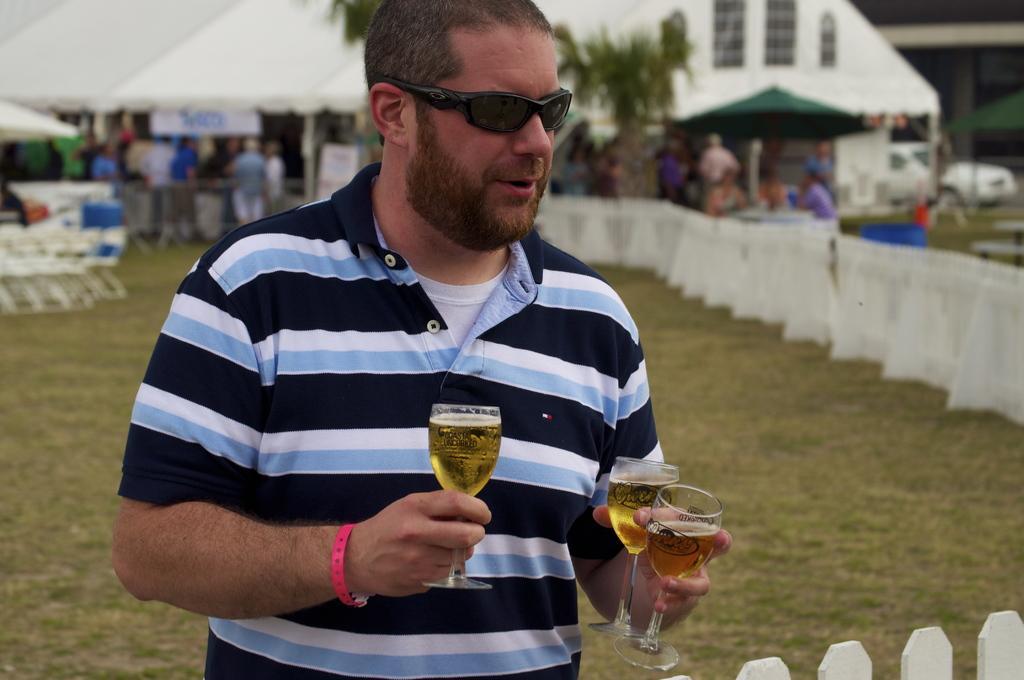Could you give a brief overview of what you see in this image? There is a person standing in the center and he is holding a wine glasses in his hand. In the background we can see a house on the right side and a few people are on the left side. 